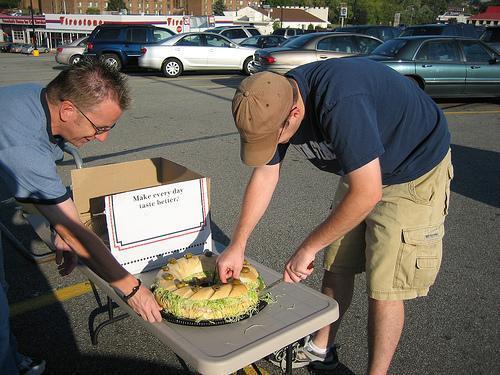How many people are wearing eyeglasses?
Give a very brief answer. 2. How many people are wearing a hat?
Give a very brief answer. 1. How many red cars are in the parking lot?
Give a very brief answer. 0. How many men are pictured?
Give a very brief answer. 2. 